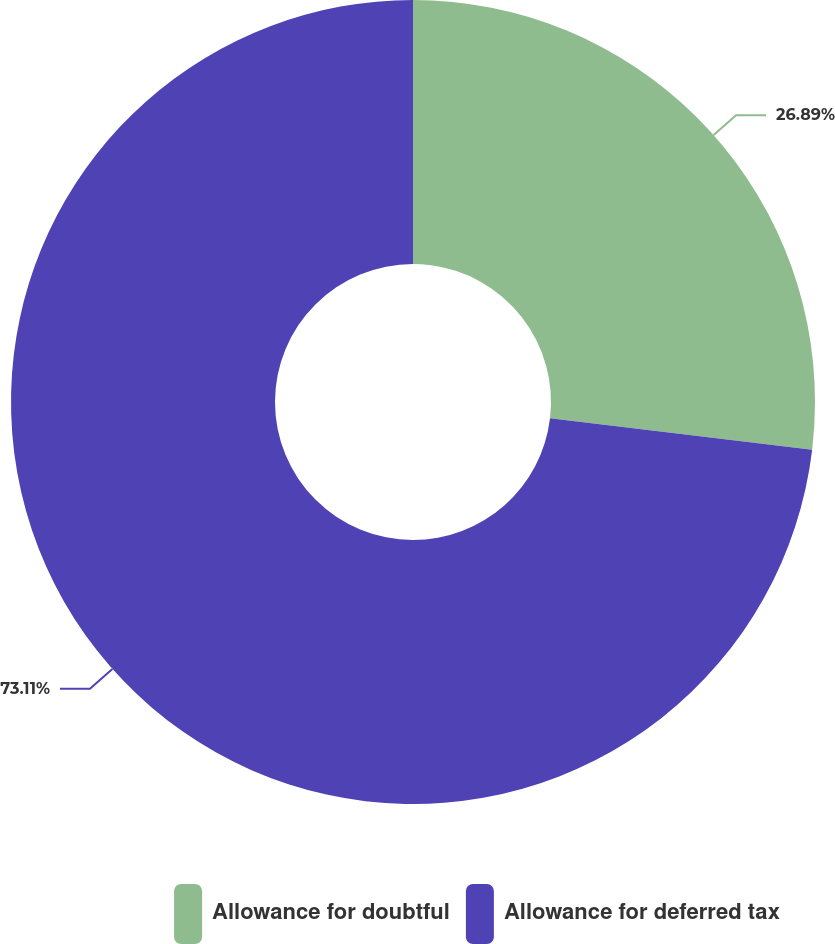Convert chart to OTSL. <chart><loc_0><loc_0><loc_500><loc_500><pie_chart><fcel>Allowance for doubtful<fcel>Allowance for deferred tax<nl><fcel>26.89%<fcel>73.11%<nl></chart> 